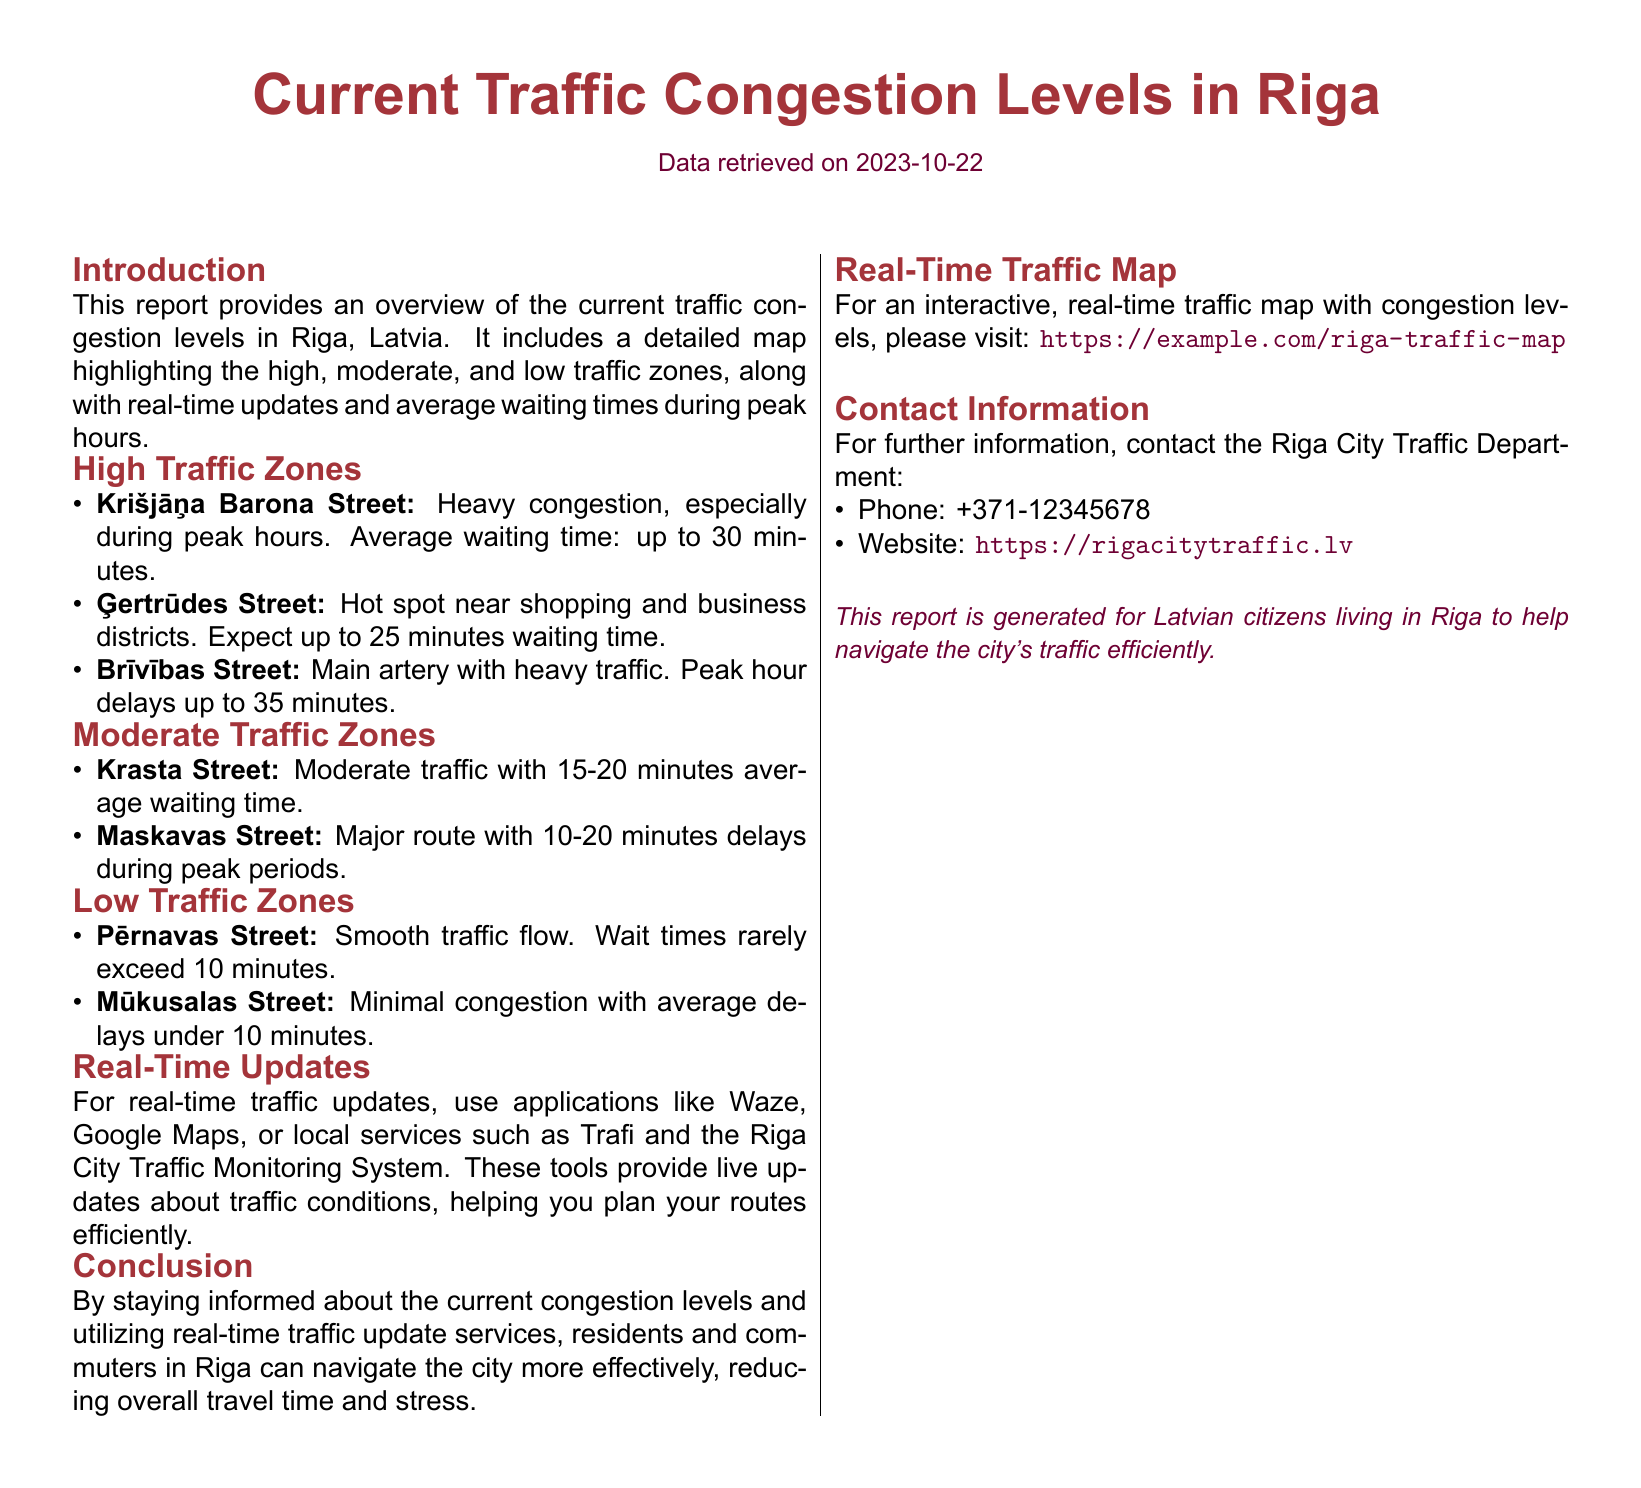What is the average waiting time on Krišjāņa Barona Street? The report states that the average waiting time on Krišjāņa Barona Street is up to 30 minutes.
Answer: up to 30 minutes What color represents high traffic zones on the map? The document highlights high traffic zones in a specific color but does not mention the color.
Answer: not specified What is the waiting time range for moderate traffic zones? The report notes that average waiting times in moderate traffic zones vary between 10 to 20 minutes.
Answer: 10-20 minutes Which street has minimal congestion? The report identifies Mūkusalas Street as having minimal congestion.
Answer: Mūkusalas Street What resource is recommended for real-time traffic updates? The document suggests using applications like Waze, Google Maps, or local services for real-time updates.
Answer: Waze, Google Maps What is the main focus of this report? The report provides information on current traffic congestion levels and assists in route planning for residents and commuters.
Answer: current traffic congestion levels How often are the waiting times mentioned in the report applicable? The waiting times mentioned in the report are specifically noted for peak hours.
Answer: peak hours Who should be contacted for further information? The report lists the Riga City Traffic Department as the contact for more information.
Answer: Riga City Traffic Department 